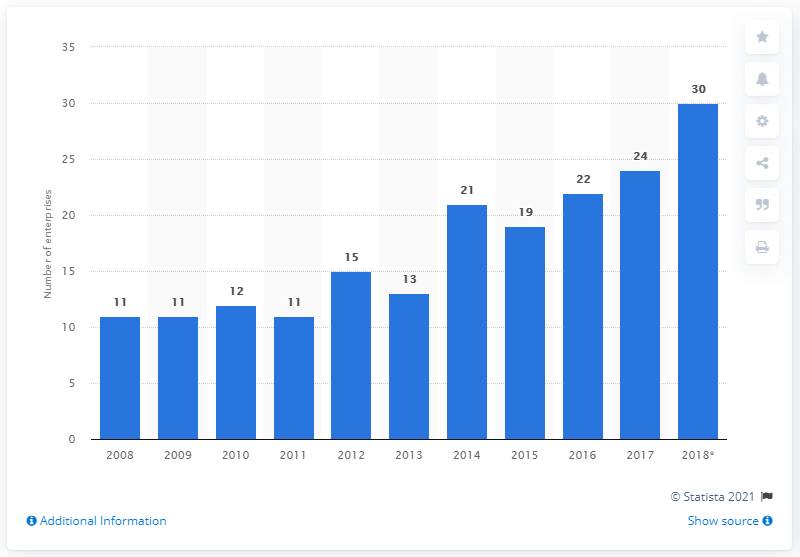Draw attention to some important aspects in this diagram. In 2018, approximately 30 enterprises processed tea and coffee in Denmark. 